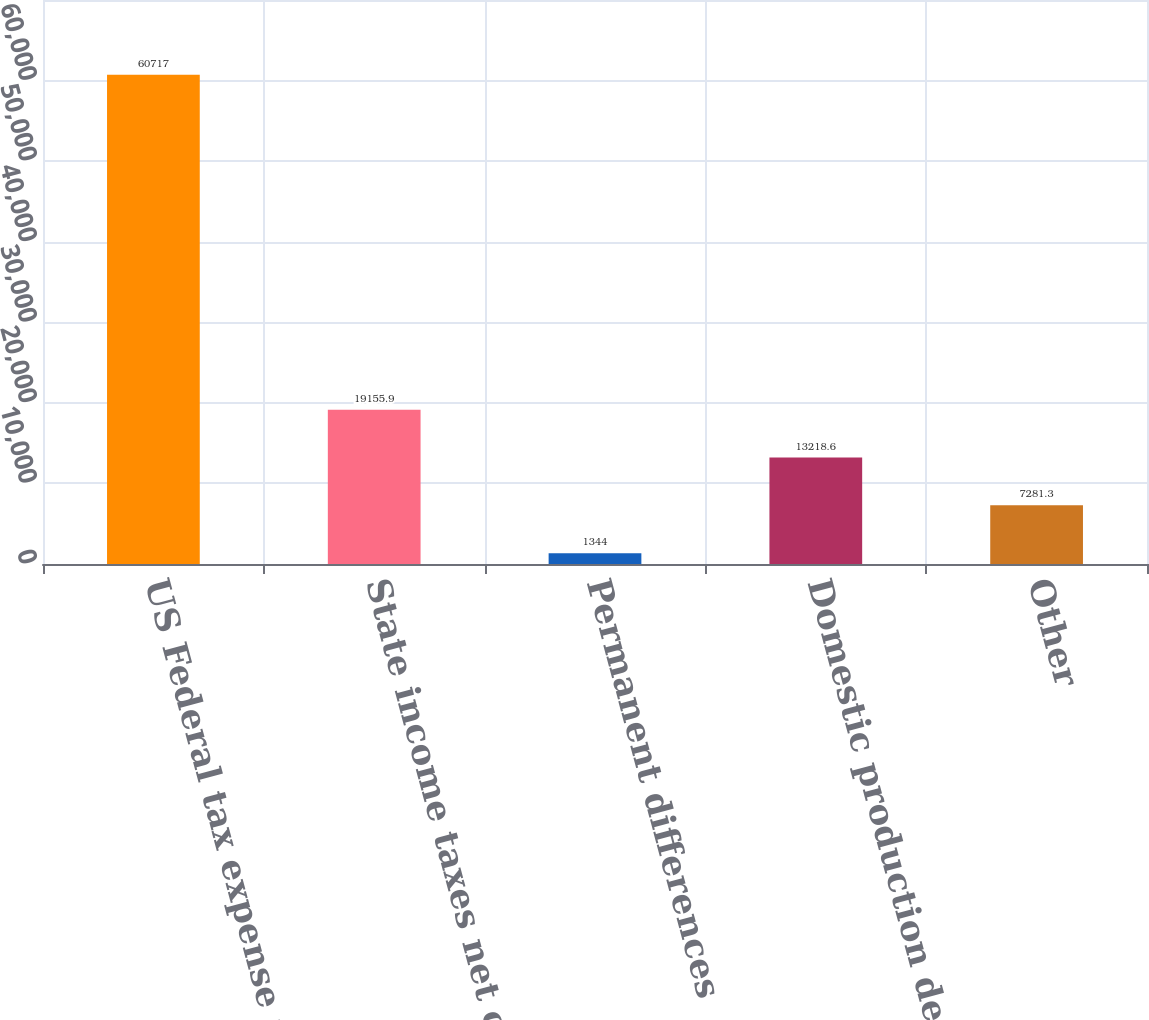Convert chart. <chart><loc_0><loc_0><loc_500><loc_500><bar_chart><fcel>US Federal tax expense at<fcel>State income taxes net of<fcel>Permanent differences<fcel>Domestic production deduction<fcel>Other<nl><fcel>60717<fcel>19155.9<fcel>1344<fcel>13218.6<fcel>7281.3<nl></chart> 